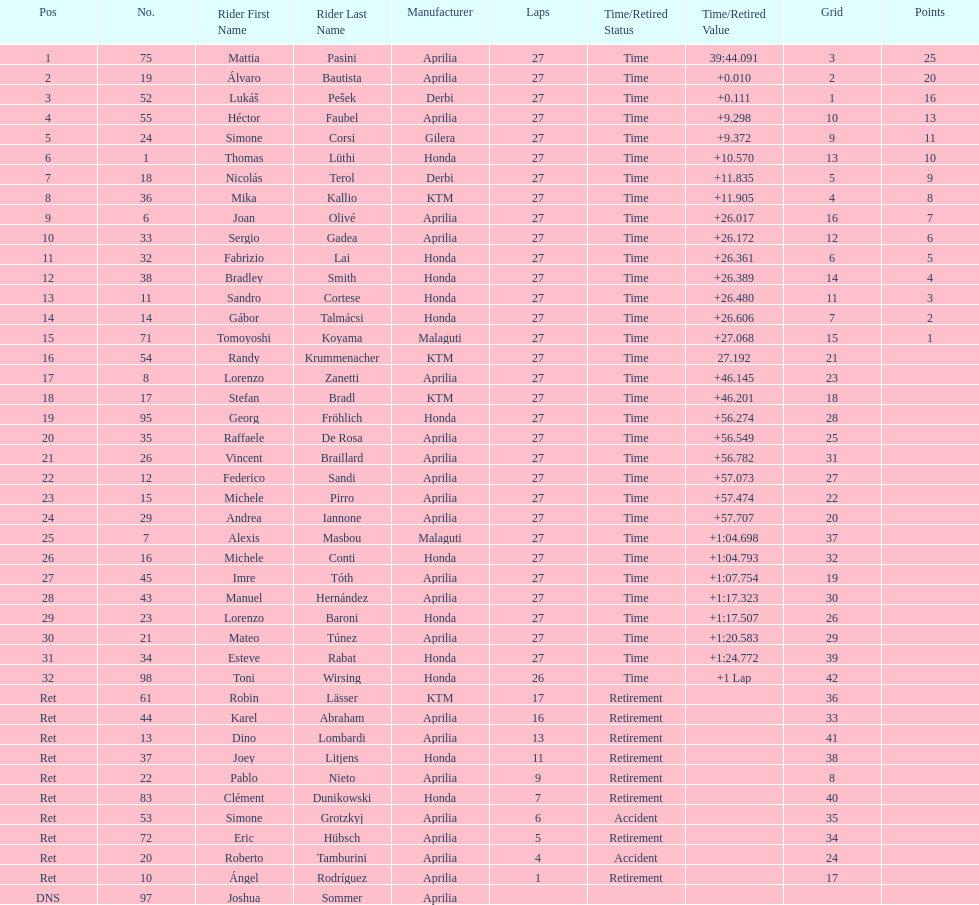Out of all the people who have points, who has the least? Tomoyoshi Koyama. 